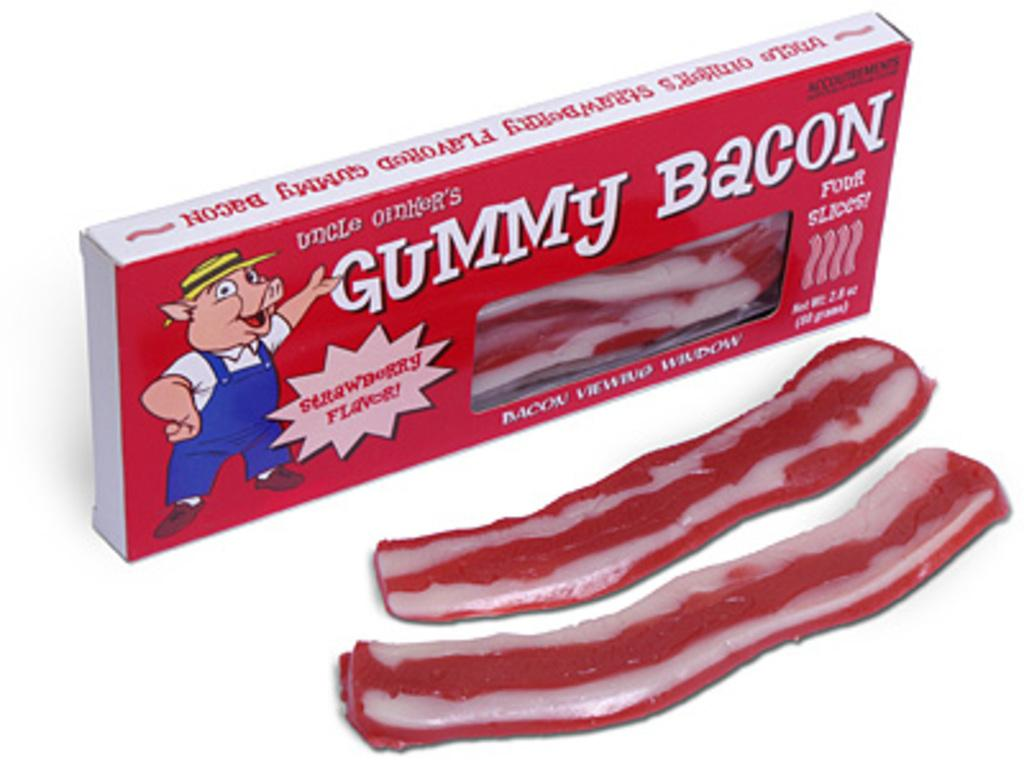What object is present in the image that could contain items? There is a box in the image. What is on the surface of the box? Chewing gums are on the surface of the box. What can be found on the box besides the chewing gums? There is text and a cartoon image on the box. What degree of difficulty is the bomb on the box rated? There is no bomb present in the image; it is a box with chewing gums, text, and a cartoon image. 